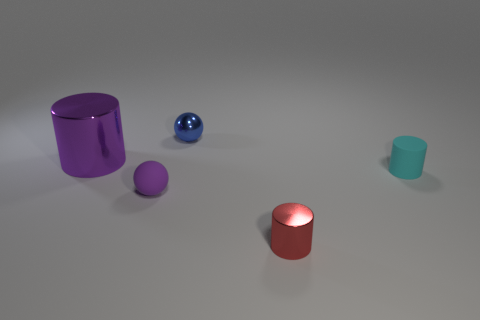Is the shape of the cyan object in front of the blue thing the same as  the purple rubber thing?
Keep it short and to the point. No. What material is the purple thing that is on the right side of the large shiny thing?
Your answer should be compact. Rubber. What is the shape of the object that is on the left side of the red thing and in front of the big cylinder?
Ensure brevity in your answer.  Sphere. What is the tiny red object made of?
Your answer should be compact. Metal. What number of cylinders are red metal objects or matte objects?
Provide a succinct answer. 2. Does the tiny red cylinder have the same material as the tiny purple thing?
Make the answer very short. No. What size is the red metallic object that is the same shape as the large purple thing?
Keep it short and to the point. Small. There is a cylinder that is to the left of the cyan matte cylinder and behind the tiny red cylinder; what is its material?
Provide a succinct answer. Metal. Is the number of small blue shiny things in front of the small metal cylinder the same as the number of purple things?
Your response must be concise. No. How many things are either tiny matte things that are to the left of the cyan thing or small purple things?
Provide a succinct answer. 1. 